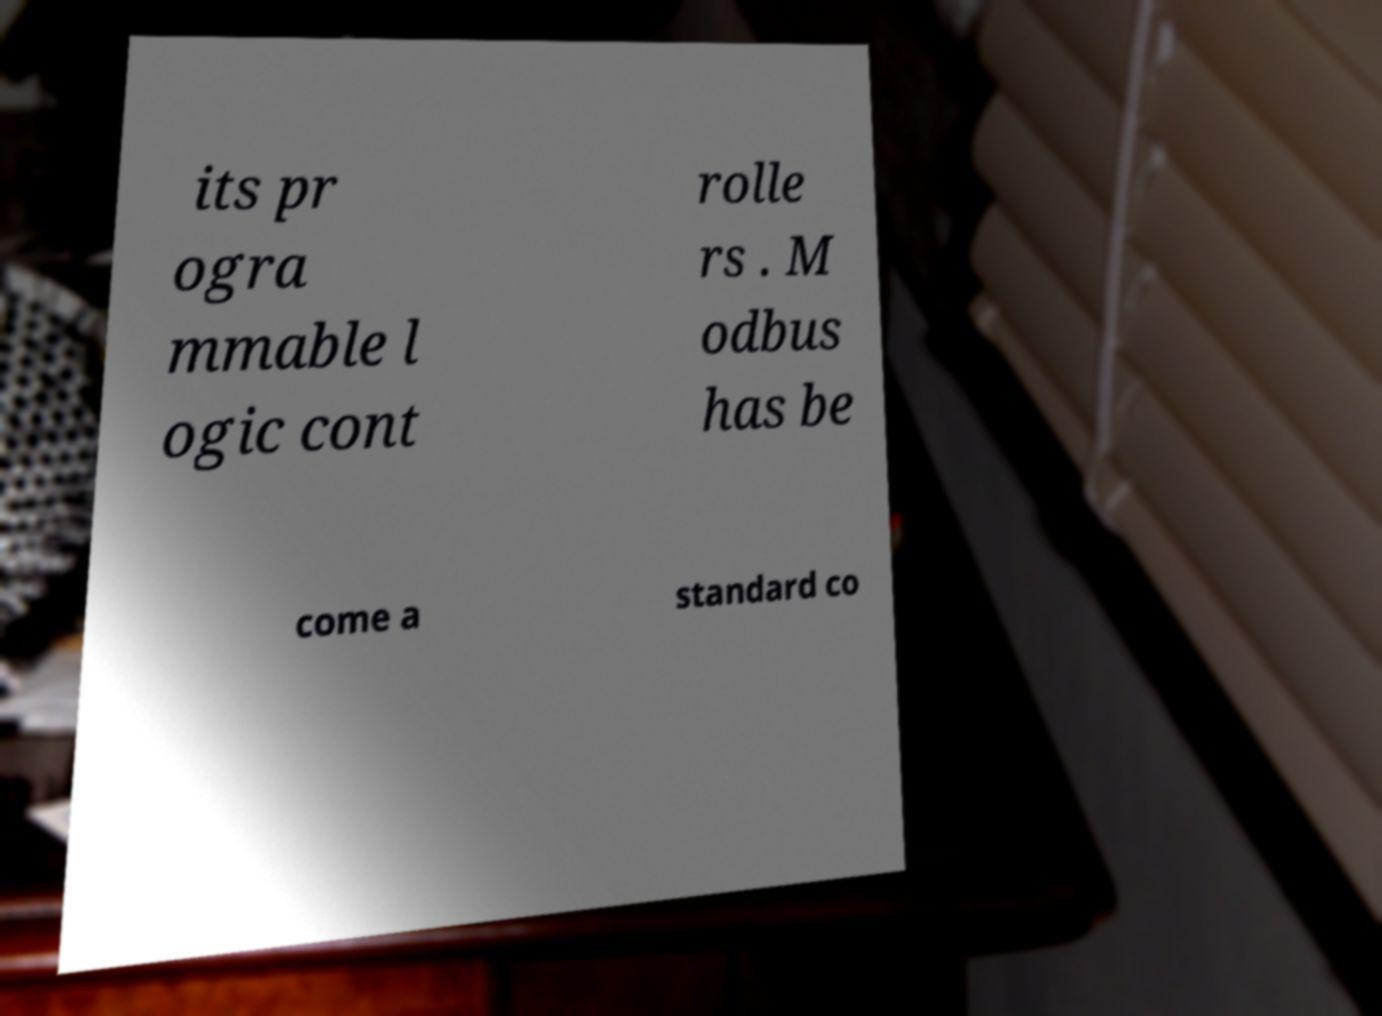Could you assist in decoding the text presented in this image and type it out clearly? its pr ogra mmable l ogic cont rolle rs . M odbus has be come a standard co 